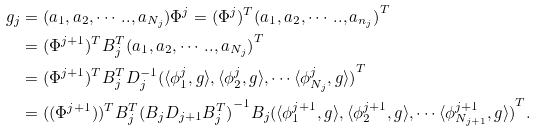<formula> <loc_0><loc_0><loc_500><loc_500>g _ { j } & = ( a _ { 1 } , a _ { 2 } , \cdots . . , a _ { N _ { j } } ) \Phi ^ { j } = ( { \Phi ^ { j } } ) ^ { T } { ( a _ { 1 } , a _ { 2 } , \cdots . . , a _ { n _ { j } } ) } ^ { T } \\ & = ( { \Phi ^ { j + 1 } } ) ^ { T } B _ { j } ^ { T } { ( a _ { 1 } , a _ { 2 } , \cdots . . , a _ { N _ { j } } ) } ^ { T } \\ & = ( { \Phi ^ { j + 1 } } ) ^ { T } B _ { j } ^ { T } D _ { j } ^ { - 1 } { ( \langle \phi ^ { j } _ { 1 } , g \rangle , \langle \phi ^ { j } _ { 2 } , g \rangle , \cdots \langle \phi ^ { j } _ { N _ { j } } , g \rangle ) } ^ { T } \\ & = ( { ( \Phi ^ { j + 1 } ) } ) ^ { T } B _ { j } ^ { T } { ( B _ { j } D _ { j + 1 } B _ { j } ^ { T } ) } ^ { - 1 } B _ { j } { ( \langle \phi ^ { j + 1 } _ { 1 } , g \rangle , \langle \phi ^ { j + 1 } _ { 2 } , g \rangle , \cdots \langle \phi ^ { j + 1 } _ { N _ { j + 1 } } , g \rangle ) } ^ { T } . \\</formula> 